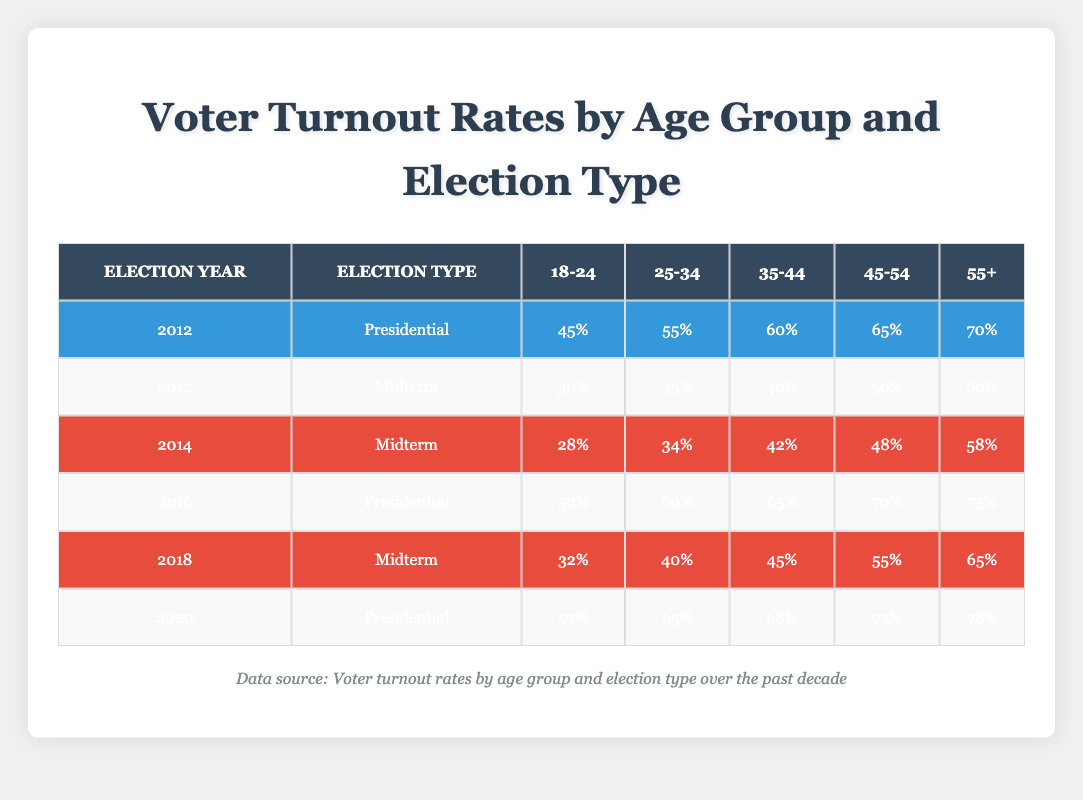What was the voter turnout rate for 25-34 age group in the 2016 Presidential election? In the 2016 Presidential election, the turnout rate for the 25-34 age group is stated as 60% in the table.
Answer: 60% Which age group had the highest voter turnout rate in the 2020 Presidential election? The data for the 2020 Presidential election shows that the 55+ age group had the highest turnout rate at 78%.
Answer: 55+ What is the difference in voter turnout rates between the 45-54 age group in the 2012 Midterm and the 2020 Presidential elections? In the 2012 Midterm election, the turnout rate for the 45-54 age group was 50%, and in the 2020 Presidential election, it was 72%. The difference is 72% - 50% = 22%.
Answer: 22% Is it true that the turnout rate for the 18-24 age group increased from the 2012 Midterm to the 2016 Presidential election? The turnout rate for the 18-24 age group in the 2012 Midterm election was 30% and in the 2016 Presidential election it increased to 50%. Therefore, it is true that the turnout rate increased.
Answer: Yes What was the average voter turnout rate for the 35-44 age group across all elections in the table? The turnout rates for the 35-44 age group in the elections are: 60% (2012 Presidential), 65% (2016 Presidential), 68% (2020 Presidential), 40% (2012 Midterm), 42% (2014 Midterm), 45% (2018 Midterm). Adding these together gives 60 + 65 + 68 + 40 + 42 + 45 = 320%. There are 6 data points, so the average is 320% / 6 = 53.33%.
Answer: 53.33% Which election type generally has higher voter turnout rates for the youngest age group (18-24) in the years provided? By comparing the turnout rates for the 18-24 age group in Presidential elections (45% in 2012, 50% in 2016, and 52% in 2020) and Midterm elections (30% in 2012, 28% in 2014, and 32% in 2018), we see that the Presidential elections consistently have higher rates: 45%, 50%, 52% compared to 30%, 28%, and 32%. Therefore, Presidential elections have higher turnout rates for the 18-24 age group.
Answer: Presidential elections 